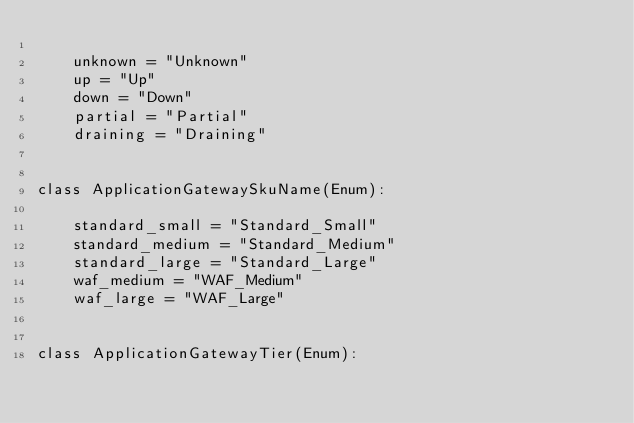Convert code to text. <code><loc_0><loc_0><loc_500><loc_500><_Python_>
    unknown = "Unknown"
    up = "Up"
    down = "Down"
    partial = "Partial"
    draining = "Draining"


class ApplicationGatewaySkuName(Enum):

    standard_small = "Standard_Small"
    standard_medium = "Standard_Medium"
    standard_large = "Standard_Large"
    waf_medium = "WAF_Medium"
    waf_large = "WAF_Large"


class ApplicationGatewayTier(Enum):
</code> 